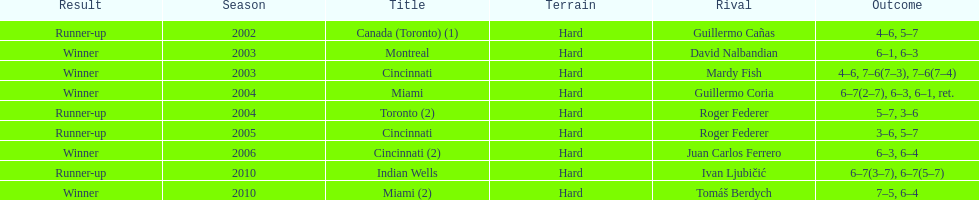How many times were roddick's opponents not from the usa? 8. 